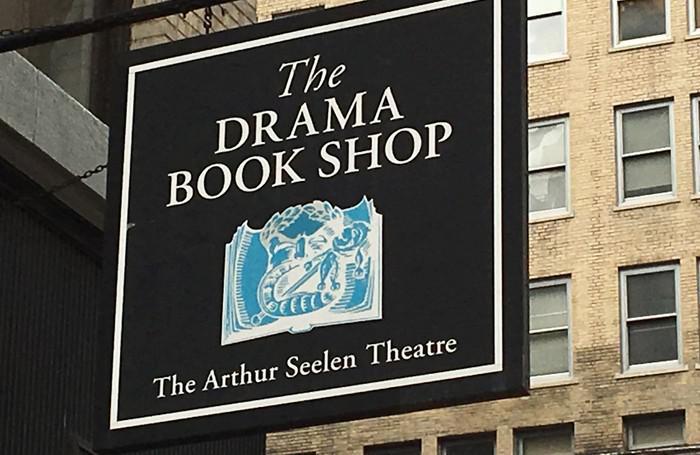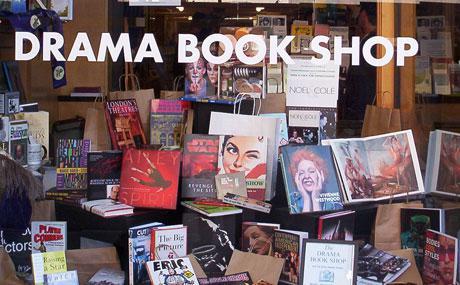The first image is the image on the left, the second image is the image on the right. Considering the images on both sides, is "There are no people in the image on the left" valid? Answer yes or no. Yes. The first image is the image on the left, the second image is the image on the right. Given the left and right images, does the statement "An image shows the interior of a bookstore, with cluster of shoppers not behind glass." hold true? Answer yes or no. No. 